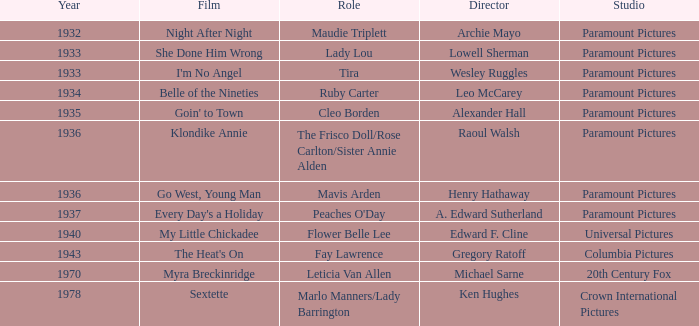What is the production year of the movie belle of the nineties? 1934.0. 